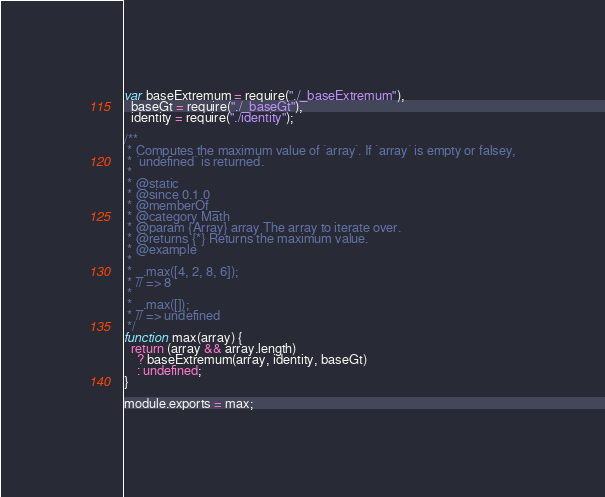<code> <loc_0><loc_0><loc_500><loc_500><_JavaScript_>var baseExtremum = require("./_baseExtremum"),
  baseGt = require("./_baseGt"),
  identity = require("./identity");

/**
 * Computes the maximum value of `array`. If `array` is empty or falsey,
 * `undefined` is returned.
 *
 * @static
 * @since 0.1.0
 * @memberOf _
 * @category Math
 * @param {Array} array The array to iterate over.
 * @returns {*} Returns the maximum value.
 * @example
 *
 * _.max([4, 2, 8, 6]);
 * // => 8
 *
 * _.max([]);
 * // => undefined
 */
function max(array) {
  return (array && array.length)
    ? baseExtremum(array, identity, baseGt)
    : undefined;
}

module.exports = max;
</code> 